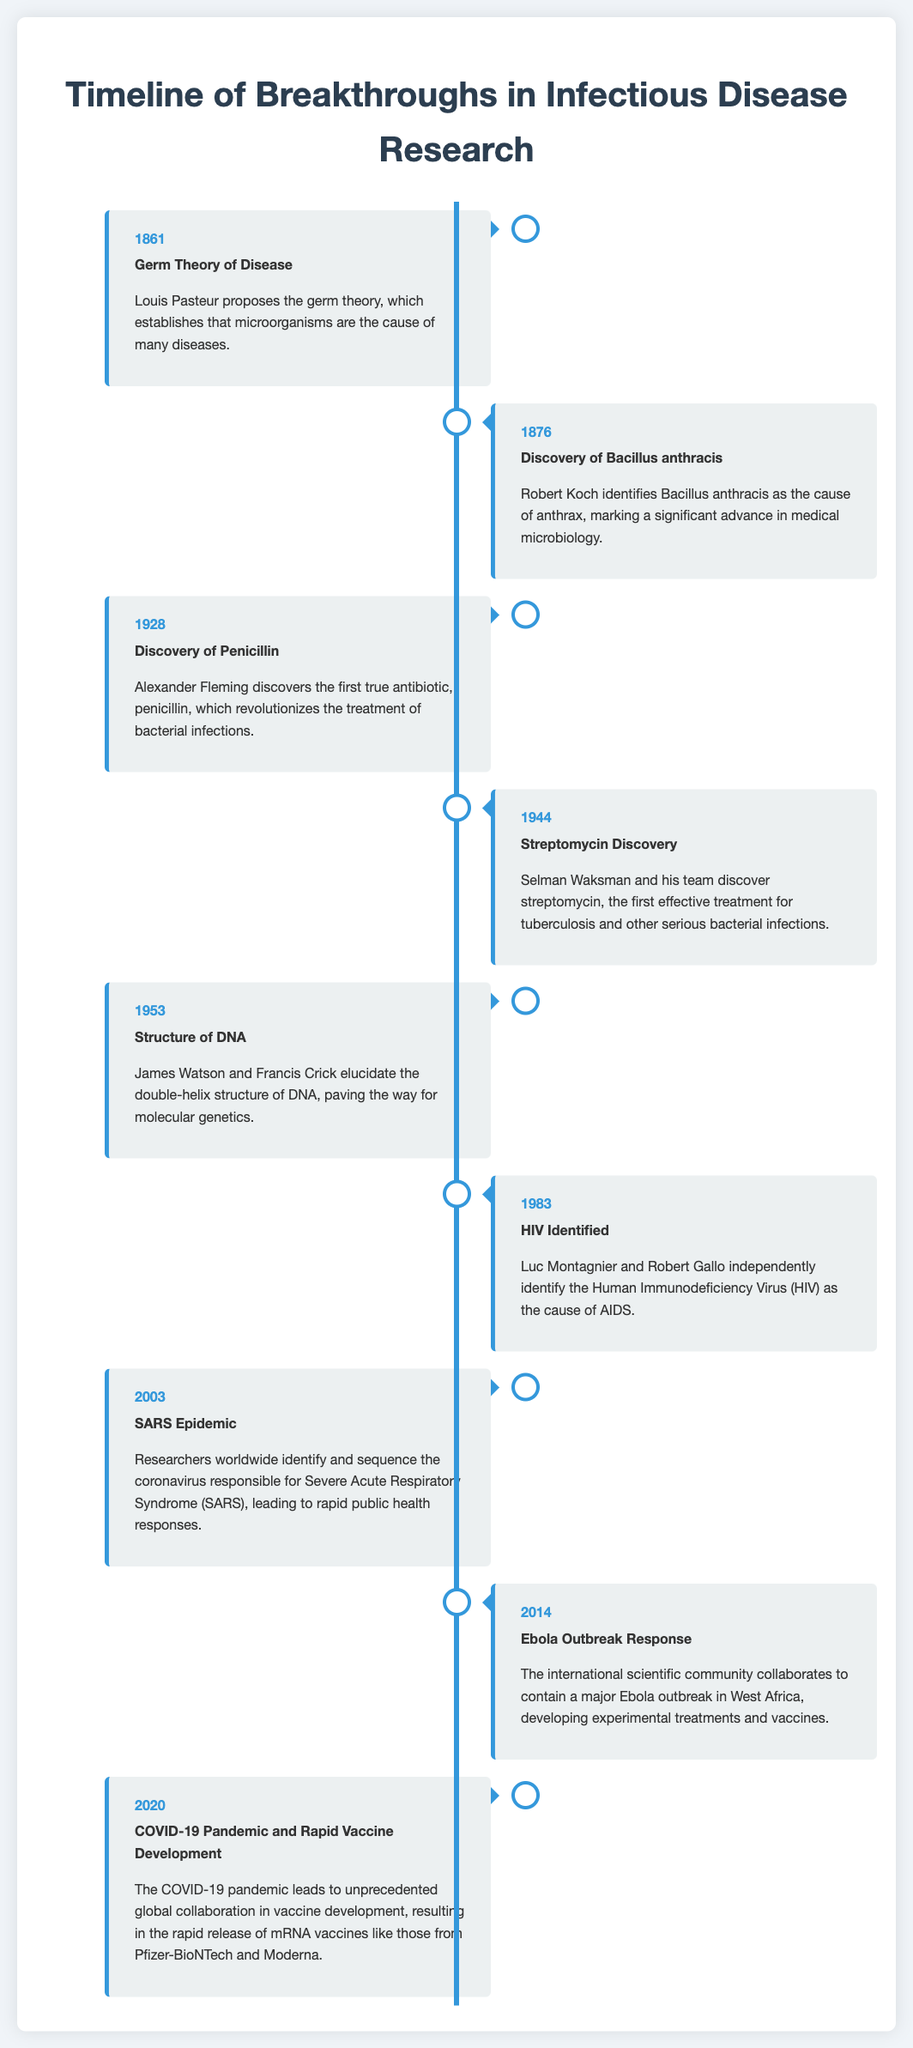What year was the Germ Theory of Disease proposed? The Germ Theory of Disease was proposed in 1861, as stated in the timeline.
Answer: 1861 Who discovered Penicillin? Penicillin was discovered by Alexander Fleming in 1928, according to the document.
Answer: Alexander Fleming What significant discovery did Robert Koch make in 1876? Robert Koch identified the cause of anthrax, specifically Bacillus anthracis, in 1876.
Answer: Bacillus anthracis Which year marks the identification of HIV? The identification of HIV occurred in 1983, as mentioned in the timeline.
Answer: 1983 What major public health response occurred in relation to SARS? In 2003, researchers identified and sequenced the coronavirus responsible for SARS, leading to rapid public health responses.
Answer: Identified and sequenced the coronavirus What was the outcome of the 2020 COVID-19 pandemic? The COVID-19 pandemic led to the rapid development and release of mRNA vaccines.
Answer: mRNA vaccines How many significant milestones are outlined in this timeline? There are eight significant milestones highlighted in the timeline.
Answer: Eight What type of timeline is this document presenting? This document is presenting a timeline of breakthroughs in infectious disease research.
Answer: Timeline of breakthroughs in infectious disease research In which year was Streptomycin discovered? Streptomycin was discovered in 1944, as indicated in the timeline.
Answer: 1944 